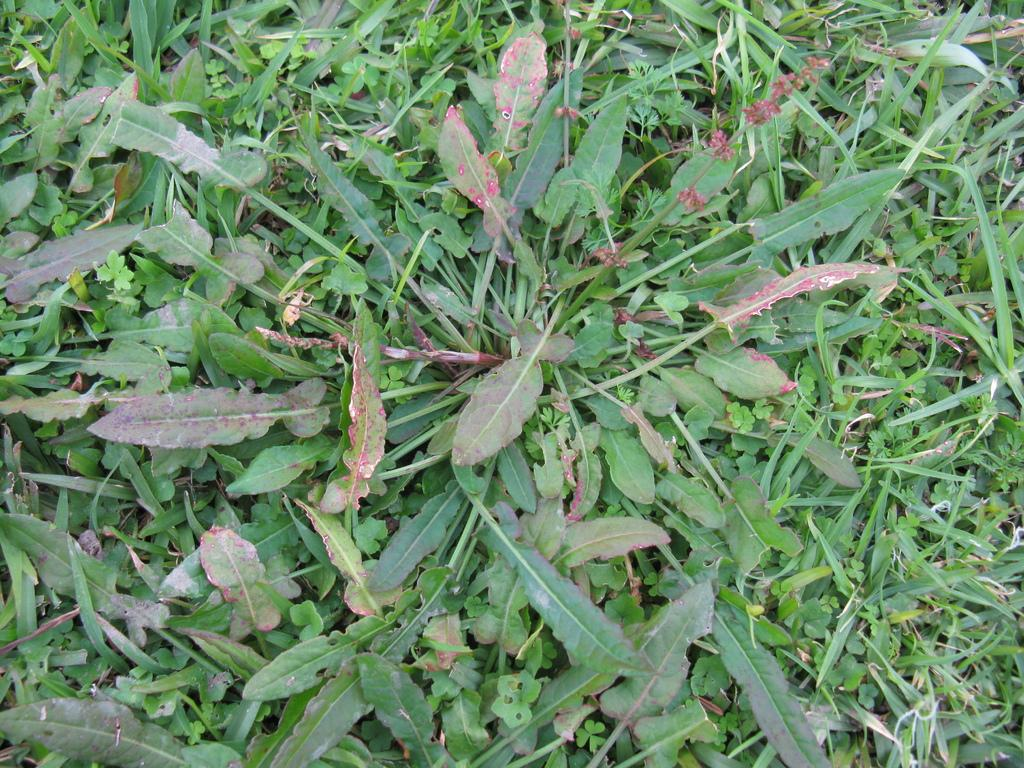What type of vegetation can be seen in the image? There are plants and grass in the image. Can you describe the natural environment depicted in the image? The image features plants and grass, which suggests a natural setting. What type of zebra can be seen grazing on the grass in the image? There is no zebra present in the image; it only features plants and grass. Can you describe the police presence in the image? There is no police presence depicted in the image; it only features plants and grass. 